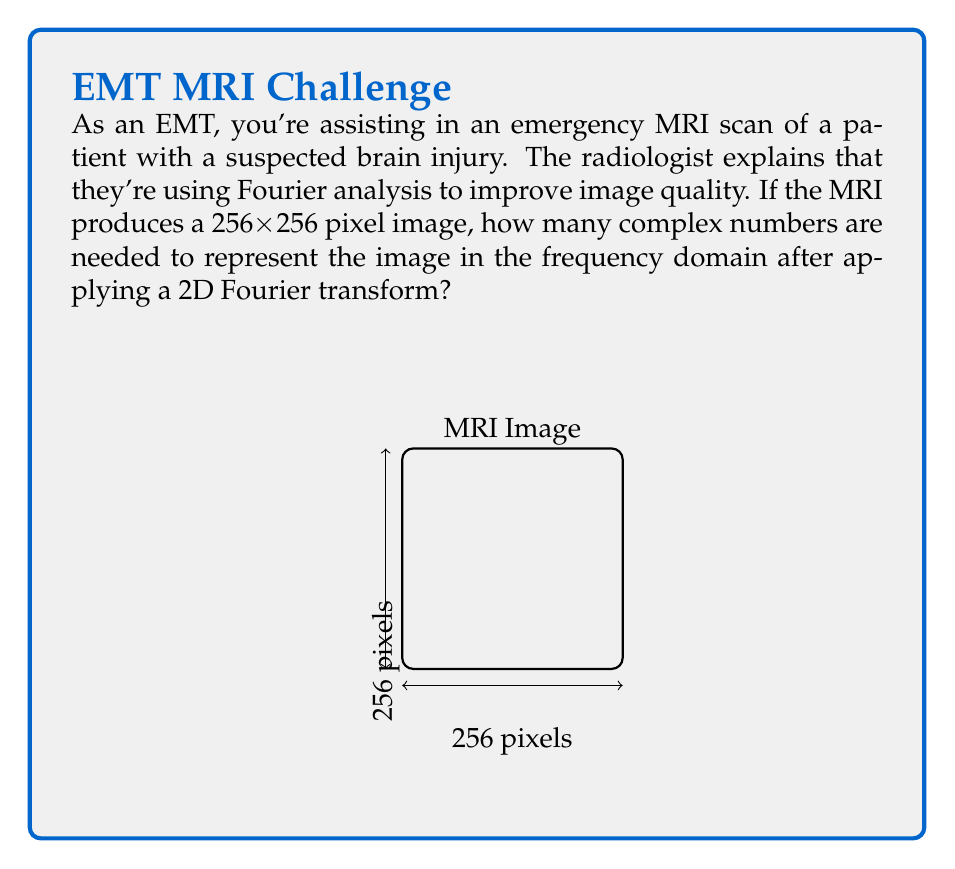What is the answer to this math problem? Let's break this down step-by-step:

1) The MRI image is 256x256 pixels, which means it's a 2D array of intensity values.

2) When we apply a 2D Fourier transform to an image, we convert it from the spatial domain to the frequency domain.

3) The 2D Fourier transform preserves the dimensions of the original image. This means the frequency domain representation will also be 256x256.

4) However, each point in the frequency domain is represented by a complex number, which contains both magnitude and phase information.

5) The number of complex numbers needed is equal to the total number of pixels in the image.

6) To calculate this, we multiply the dimensions of the image:

   $$256 \times 256 = 65,536$$

Therefore, 65,536 complex numbers are needed to represent the MRI image in the frequency domain after applying a 2D Fourier transform.

This transformation allows for various image processing techniques that can enhance diagnostic accuracy, such as filtering out noise or emphasizing certain frequency components.
Answer: 65,536 complex numbers 